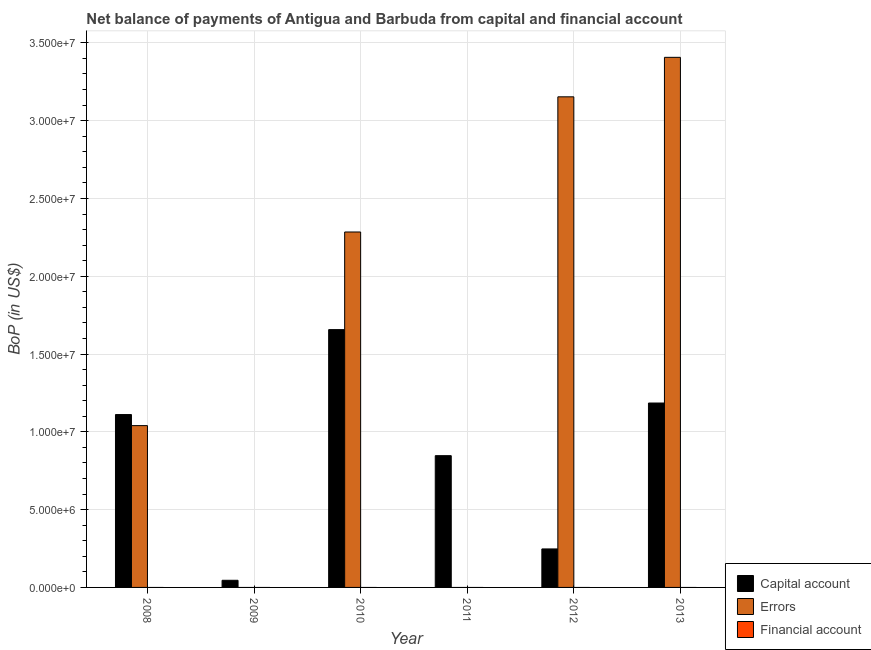How many different coloured bars are there?
Provide a succinct answer. 2. What is the label of the 5th group of bars from the left?
Provide a succinct answer. 2012. What is the amount of net capital account in 2013?
Keep it short and to the point. 1.19e+07. Across all years, what is the maximum amount of net capital account?
Your response must be concise. 1.66e+07. In which year was the amount of net capital account maximum?
Provide a succinct answer. 2010. What is the total amount of net capital account in the graph?
Your answer should be very brief. 5.09e+07. What is the difference between the amount of errors in 2012 and that in 2013?
Provide a short and direct response. -2.54e+06. What is the difference between the amount of financial account in 2011 and the amount of net capital account in 2009?
Offer a terse response. 0. What is the average amount of financial account per year?
Offer a terse response. 0. What is the ratio of the amount of errors in 2010 to that in 2013?
Give a very brief answer. 0.67. Is the amount of net capital account in 2008 less than that in 2010?
Your response must be concise. Yes. What is the difference between the highest and the second highest amount of net capital account?
Provide a succinct answer. 4.72e+06. What is the difference between the highest and the lowest amount of net capital account?
Your answer should be very brief. 1.61e+07. Is it the case that in every year, the sum of the amount of net capital account and amount of errors is greater than the amount of financial account?
Ensure brevity in your answer.  Yes. Does the graph contain grids?
Your answer should be very brief. Yes. Where does the legend appear in the graph?
Your answer should be very brief. Bottom right. How are the legend labels stacked?
Your answer should be compact. Vertical. What is the title of the graph?
Keep it short and to the point. Net balance of payments of Antigua and Barbuda from capital and financial account. Does "Infant(male)" appear as one of the legend labels in the graph?
Give a very brief answer. No. What is the label or title of the X-axis?
Ensure brevity in your answer.  Year. What is the label or title of the Y-axis?
Keep it short and to the point. BoP (in US$). What is the BoP (in US$) of Capital account in 2008?
Make the answer very short. 1.11e+07. What is the BoP (in US$) in Errors in 2008?
Ensure brevity in your answer.  1.04e+07. What is the BoP (in US$) of Financial account in 2008?
Make the answer very short. 0. What is the BoP (in US$) of Capital account in 2009?
Ensure brevity in your answer.  4.59e+05. What is the BoP (in US$) of Financial account in 2009?
Offer a terse response. 0. What is the BoP (in US$) in Capital account in 2010?
Offer a terse response. 1.66e+07. What is the BoP (in US$) in Errors in 2010?
Keep it short and to the point. 2.28e+07. What is the BoP (in US$) in Financial account in 2010?
Provide a short and direct response. 0. What is the BoP (in US$) in Capital account in 2011?
Your answer should be very brief. 8.47e+06. What is the BoP (in US$) of Errors in 2011?
Your answer should be very brief. 0. What is the BoP (in US$) in Financial account in 2011?
Give a very brief answer. 0. What is the BoP (in US$) of Capital account in 2012?
Give a very brief answer. 2.47e+06. What is the BoP (in US$) in Errors in 2012?
Your answer should be very brief. 3.15e+07. What is the BoP (in US$) in Capital account in 2013?
Provide a succinct answer. 1.19e+07. What is the BoP (in US$) in Errors in 2013?
Your answer should be very brief. 3.41e+07. What is the BoP (in US$) in Financial account in 2013?
Give a very brief answer. 0. Across all years, what is the maximum BoP (in US$) in Capital account?
Offer a terse response. 1.66e+07. Across all years, what is the maximum BoP (in US$) in Errors?
Ensure brevity in your answer.  3.41e+07. Across all years, what is the minimum BoP (in US$) in Capital account?
Your answer should be compact. 4.59e+05. What is the total BoP (in US$) of Capital account in the graph?
Keep it short and to the point. 5.09e+07. What is the total BoP (in US$) of Errors in the graph?
Keep it short and to the point. 9.88e+07. What is the total BoP (in US$) in Financial account in the graph?
Provide a short and direct response. 0. What is the difference between the BoP (in US$) in Capital account in 2008 and that in 2009?
Keep it short and to the point. 1.07e+07. What is the difference between the BoP (in US$) of Capital account in 2008 and that in 2010?
Your response must be concise. -5.46e+06. What is the difference between the BoP (in US$) in Errors in 2008 and that in 2010?
Your response must be concise. -1.24e+07. What is the difference between the BoP (in US$) in Capital account in 2008 and that in 2011?
Your response must be concise. 2.64e+06. What is the difference between the BoP (in US$) in Capital account in 2008 and that in 2012?
Keep it short and to the point. 8.64e+06. What is the difference between the BoP (in US$) of Errors in 2008 and that in 2012?
Your answer should be compact. -2.11e+07. What is the difference between the BoP (in US$) of Capital account in 2008 and that in 2013?
Make the answer very short. -7.41e+05. What is the difference between the BoP (in US$) of Errors in 2008 and that in 2013?
Provide a short and direct response. -2.37e+07. What is the difference between the BoP (in US$) in Capital account in 2009 and that in 2010?
Give a very brief answer. -1.61e+07. What is the difference between the BoP (in US$) in Capital account in 2009 and that in 2011?
Your answer should be very brief. -8.01e+06. What is the difference between the BoP (in US$) in Capital account in 2009 and that in 2012?
Your answer should be compact. -2.02e+06. What is the difference between the BoP (in US$) in Capital account in 2009 and that in 2013?
Offer a very short reply. -1.14e+07. What is the difference between the BoP (in US$) of Capital account in 2010 and that in 2011?
Offer a very short reply. 8.10e+06. What is the difference between the BoP (in US$) in Capital account in 2010 and that in 2012?
Offer a very short reply. 1.41e+07. What is the difference between the BoP (in US$) in Errors in 2010 and that in 2012?
Keep it short and to the point. -8.69e+06. What is the difference between the BoP (in US$) in Capital account in 2010 and that in 2013?
Your response must be concise. 4.72e+06. What is the difference between the BoP (in US$) in Errors in 2010 and that in 2013?
Ensure brevity in your answer.  -1.12e+07. What is the difference between the BoP (in US$) in Capital account in 2011 and that in 2012?
Offer a very short reply. 5.99e+06. What is the difference between the BoP (in US$) in Capital account in 2011 and that in 2013?
Your response must be concise. -3.38e+06. What is the difference between the BoP (in US$) in Capital account in 2012 and that in 2013?
Your answer should be very brief. -9.38e+06. What is the difference between the BoP (in US$) in Errors in 2012 and that in 2013?
Ensure brevity in your answer.  -2.54e+06. What is the difference between the BoP (in US$) in Capital account in 2008 and the BoP (in US$) in Errors in 2010?
Ensure brevity in your answer.  -1.17e+07. What is the difference between the BoP (in US$) in Capital account in 2008 and the BoP (in US$) in Errors in 2012?
Offer a terse response. -2.04e+07. What is the difference between the BoP (in US$) of Capital account in 2008 and the BoP (in US$) of Errors in 2013?
Offer a terse response. -2.30e+07. What is the difference between the BoP (in US$) of Capital account in 2009 and the BoP (in US$) of Errors in 2010?
Keep it short and to the point. -2.24e+07. What is the difference between the BoP (in US$) in Capital account in 2009 and the BoP (in US$) in Errors in 2012?
Your answer should be compact. -3.11e+07. What is the difference between the BoP (in US$) in Capital account in 2009 and the BoP (in US$) in Errors in 2013?
Ensure brevity in your answer.  -3.36e+07. What is the difference between the BoP (in US$) in Capital account in 2010 and the BoP (in US$) in Errors in 2012?
Your response must be concise. -1.50e+07. What is the difference between the BoP (in US$) of Capital account in 2010 and the BoP (in US$) of Errors in 2013?
Your answer should be compact. -1.75e+07. What is the difference between the BoP (in US$) of Capital account in 2011 and the BoP (in US$) of Errors in 2012?
Make the answer very short. -2.31e+07. What is the difference between the BoP (in US$) of Capital account in 2011 and the BoP (in US$) of Errors in 2013?
Your response must be concise. -2.56e+07. What is the difference between the BoP (in US$) in Capital account in 2012 and the BoP (in US$) in Errors in 2013?
Offer a terse response. -3.16e+07. What is the average BoP (in US$) in Capital account per year?
Your response must be concise. 8.49e+06. What is the average BoP (in US$) in Errors per year?
Provide a short and direct response. 1.65e+07. What is the average BoP (in US$) in Financial account per year?
Your response must be concise. 0. In the year 2008, what is the difference between the BoP (in US$) of Capital account and BoP (in US$) of Errors?
Offer a terse response. 7.11e+05. In the year 2010, what is the difference between the BoP (in US$) in Capital account and BoP (in US$) in Errors?
Your answer should be very brief. -6.27e+06. In the year 2012, what is the difference between the BoP (in US$) of Capital account and BoP (in US$) of Errors?
Give a very brief answer. -2.91e+07. In the year 2013, what is the difference between the BoP (in US$) in Capital account and BoP (in US$) in Errors?
Offer a terse response. -2.22e+07. What is the ratio of the BoP (in US$) of Capital account in 2008 to that in 2009?
Offer a very short reply. 24.2. What is the ratio of the BoP (in US$) in Capital account in 2008 to that in 2010?
Provide a succinct answer. 0.67. What is the ratio of the BoP (in US$) in Errors in 2008 to that in 2010?
Provide a succinct answer. 0.46. What is the ratio of the BoP (in US$) in Capital account in 2008 to that in 2011?
Your answer should be very brief. 1.31. What is the ratio of the BoP (in US$) of Capital account in 2008 to that in 2012?
Your response must be concise. 4.49. What is the ratio of the BoP (in US$) in Errors in 2008 to that in 2012?
Provide a succinct answer. 0.33. What is the ratio of the BoP (in US$) of Capital account in 2008 to that in 2013?
Ensure brevity in your answer.  0.94. What is the ratio of the BoP (in US$) in Errors in 2008 to that in 2013?
Ensure brevity in your answer.  0.31. What is the ratio of the BoP (in US$) in Capital account in 2009 to that in 2010?
Offer a very short reply. 0.03. What is the ratio of the BoP (in US$) in Capital account in 2009 to that in 2011?
Your answer should be compact. 0.05. What is the ratio of the BoP (in US$) of Capital account in 2009 to that in 2012?
Your answer should be compact. 0.19. What is the ratio of the BoP (in US$) of Capital account in 2009 to that in 2013?
Give a very brief answer. 0.04. What is the ratio of the BoP (in US$) of Capital account in 2010 to that in 2011?
Ensure brevity in your answer.  1.96. What is the ratio of the BoP (in US$) of Capital account in 2010 to that in 2012?
Your answer should be compact. 6.7. What is the ratio of the BoP (in US$) of Errors in 2010 to that in 2012?
Offer a very short reply. 0.72. What is the ratio of the BoP (in US$) of Capital account in 2010 to that in 2013?
Your answer should be very brief. 1.4. What is the ratio of the BoP (in US$) of Errors in 2010 to that in 2013?
Your answer should be very brief. 0.67. What is the ratio of the BoP (in US$) in Capital account in 2011 to that in 2012?
Keep it short and to the point. 3.42. What is the ratio of the BoP (in US$) in Capital account in 2011 to that in 2013?
Your response must be concise. 0.71. What is the ratio of the BoP (in US$) in Capital account in 2012 to that in 2013?
Keep it short and to the point. 0.21. What is the ratio of the BoP (in US$) of Errors in 2012 to that in 2013?
Provide a succinct answer. 0.93. What is the difference between the highest and the second highest BoP (in US$) of Capital account?
Provide a short and direct response. 4.72e+06. What is the difference between the highest and the second highest BoP (in US$) in Errors?
Your answer should be very brief. 2.54e+06. What is the difference between the highest and the lowest BoP (in US$) in Capital account?
Your answer should be very brief. 1.61e+07. What is the difference between the highest and the lowest BoP (in US$) of Errors?
Provide a short and direct response. 3.41e+07. 